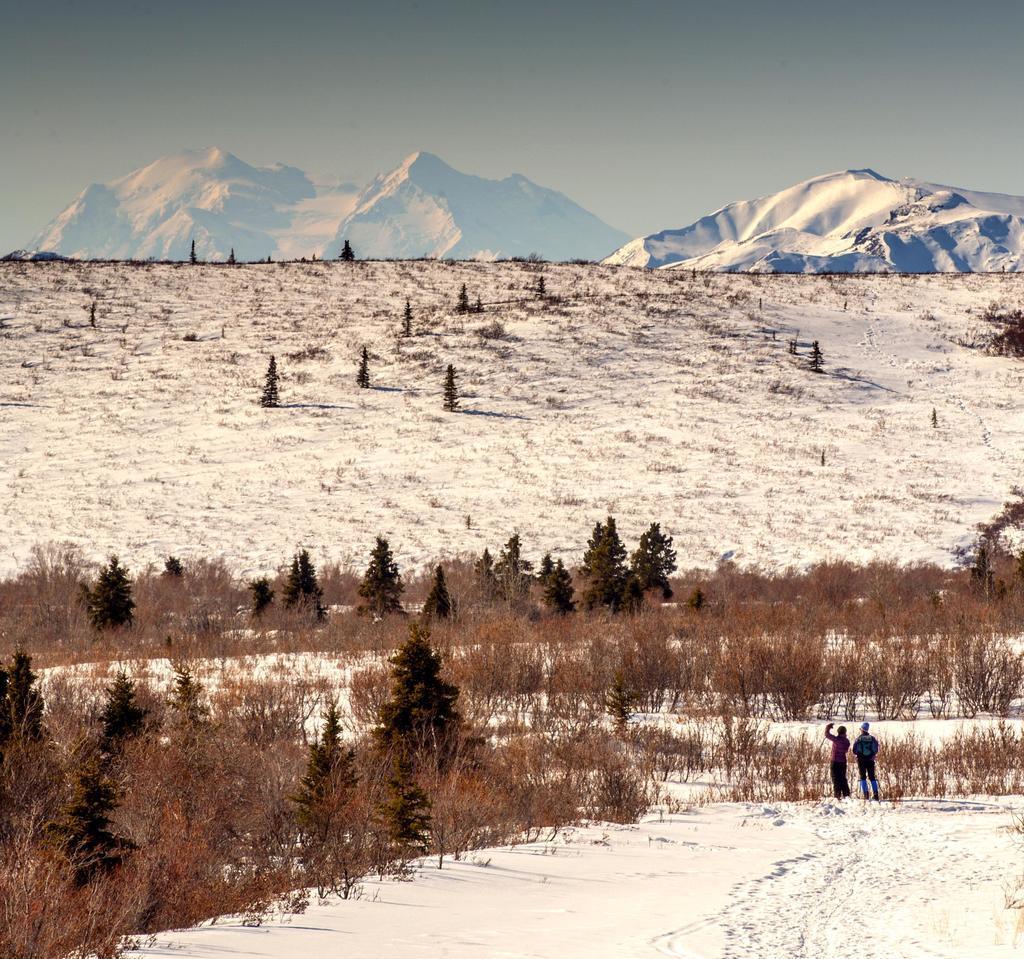Can you describe this image briefly? In this picture we can see there are two people standing and in front of the people there are trees, snowy hills and a sky. 